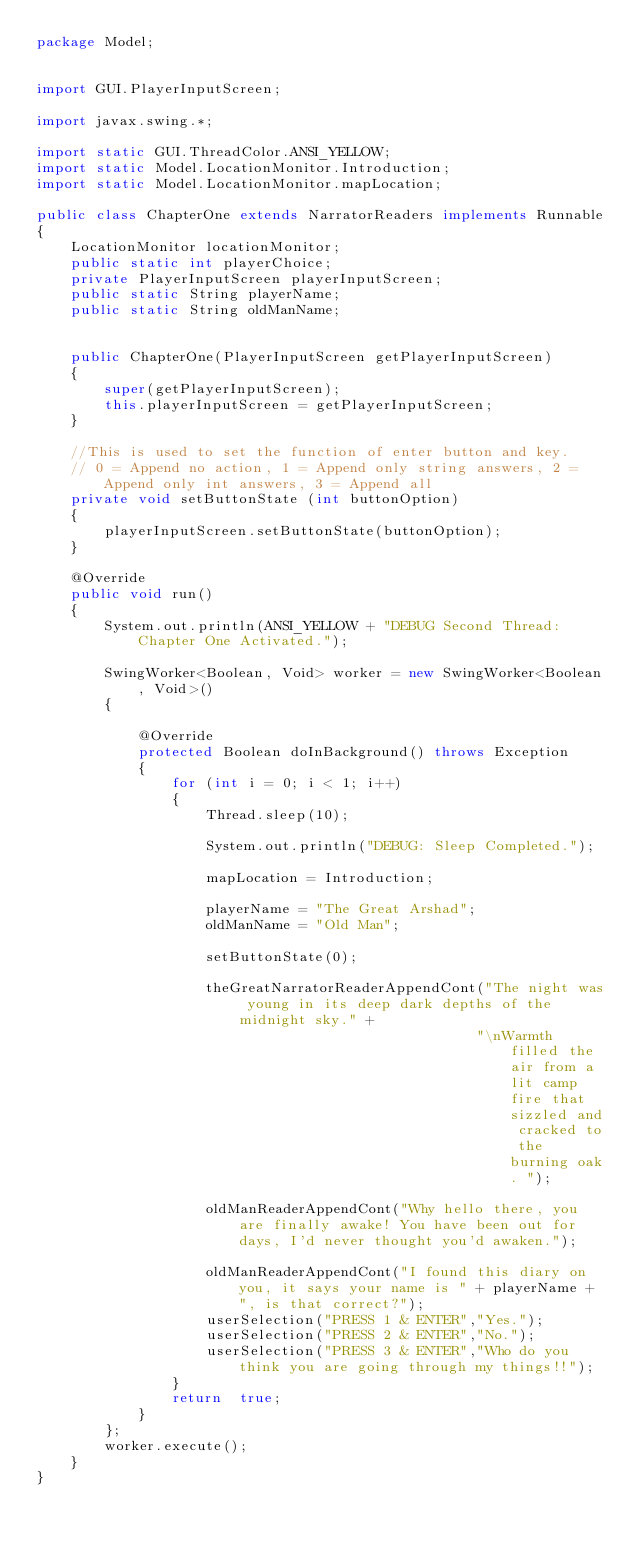Convert code to text. <code><loc_0><loc_0><loc_500><loc_500><_Java_>package Model;


import GUI.PlayerInputScreen;

import javax.swing.*;

import static GUI.ThreadColor.ANSI_YELLOW;
import static Model.LocationMonitor.Introduction;
import static Model.LocationMonitor.mapLocation;

public class ChapterOne extends NarratorReaders implements Runnable
{
    LocationMonitor locationMonitor;
    public static int playerChoice;
    private PlayerInputScreen playerInputScreen;
    public static String playerName;
    public static String oldManName;


    public ChapterOne(PlayerInputScreen getPlayerInputScreen)
    {
        super(getPlayerInputScreen);
        this.playerInputScreen = getPlayerInputScreen;
    }

    //This is used to set the function of enter button and key.
    // 0 = Append no action, 1 = Append only string answers, 2 = Append only int answers, 3 = Append all
    private void setButtonState (int buttonOption)
    {
        playerInputScreen.setButtonState(buttonOption);
    }

    @Override
    public void run()
    {
        System.out.println(ANSI_YELLOW + "DEBUG Second Thread: Chapter One Activated.");

        SwingWorker<Boolean, Void> worker = new SwingWorker<Boolean, Void>()
        {

            @Override
            protected Boolean doInBackground() throws Exception
            {
                for (int i = 0; i < 1; i++)
                {
                    Thread.sleep(10);

                    System.out.println("DEBUG: Sleep Completed.");

                    mapLocation = Introduction;

                    playerName = "The Great Arshad";
                    oldManName = "Old Man";

                    setButtonState(0);

                    theGreatNarratorReaderAppendCont("The night was young in its deep dark depths of the midnight sky." +
                                                    "\nWarmth filled the air from a lit camp fire that sizzled and cracked to the burning oak. ");

                    oldManReaderAppendCont("Why hello there, you are finally awake! You have been out for days, I'd never thought you'd awaken.");

                    oldManReaderAppendCont("I found this diary on you, it says your name is " + playerName + ", is that correct?");
                    userSelection("PRESS 1 & ENTER","Yes.");
                    userSelection("PRESS 2 & ENTER","No.");
                    userSelection("PRESS 3 & ENTER","Who do you think you are going through my things!!");
                }
                return  true;
            }
        };
        worker.execute();
    }
}</code> 